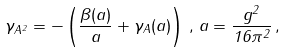<formula> <loc_0><loc_0><loc_500><loc_500>\gamma _ { A ^ { 2 } } = - \left ( \frac { \beta ( a ) } { a } + \gamma _ { A } ( a ) \right ) \, , \, a = \frac { g ^ { 2 } } { 1 6 \pi ^ { 2 } } \, ,</formula> 